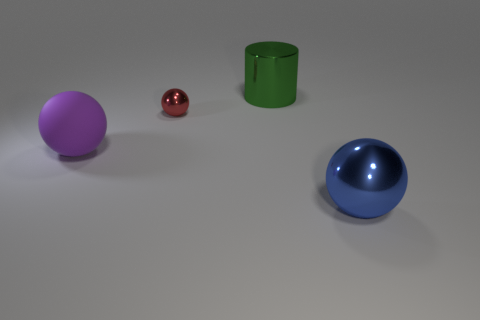Subtract all blue balls. How many balls are left? 2 Add 2 big blue matte balls. How many objects exist? 6 Subtract all red balls. How many balls are left? 2 Subtract 1 cylinders. How many cylinders are left? 0 Subtract all cylinders. How many objects are left? 3 Subtract all rubber objects. Subtract all green shiny cylinders. How many objects are left? 2 Add 2 small balls. How many small balls are left? 3 Add 4 large rubber objects. How many large rubber objects exist? 5 Subtract 0 gray balls. How many objects are left? 4 Subtract all red cylinders. Subtract all gray balls. How many cylinders are left? 1 